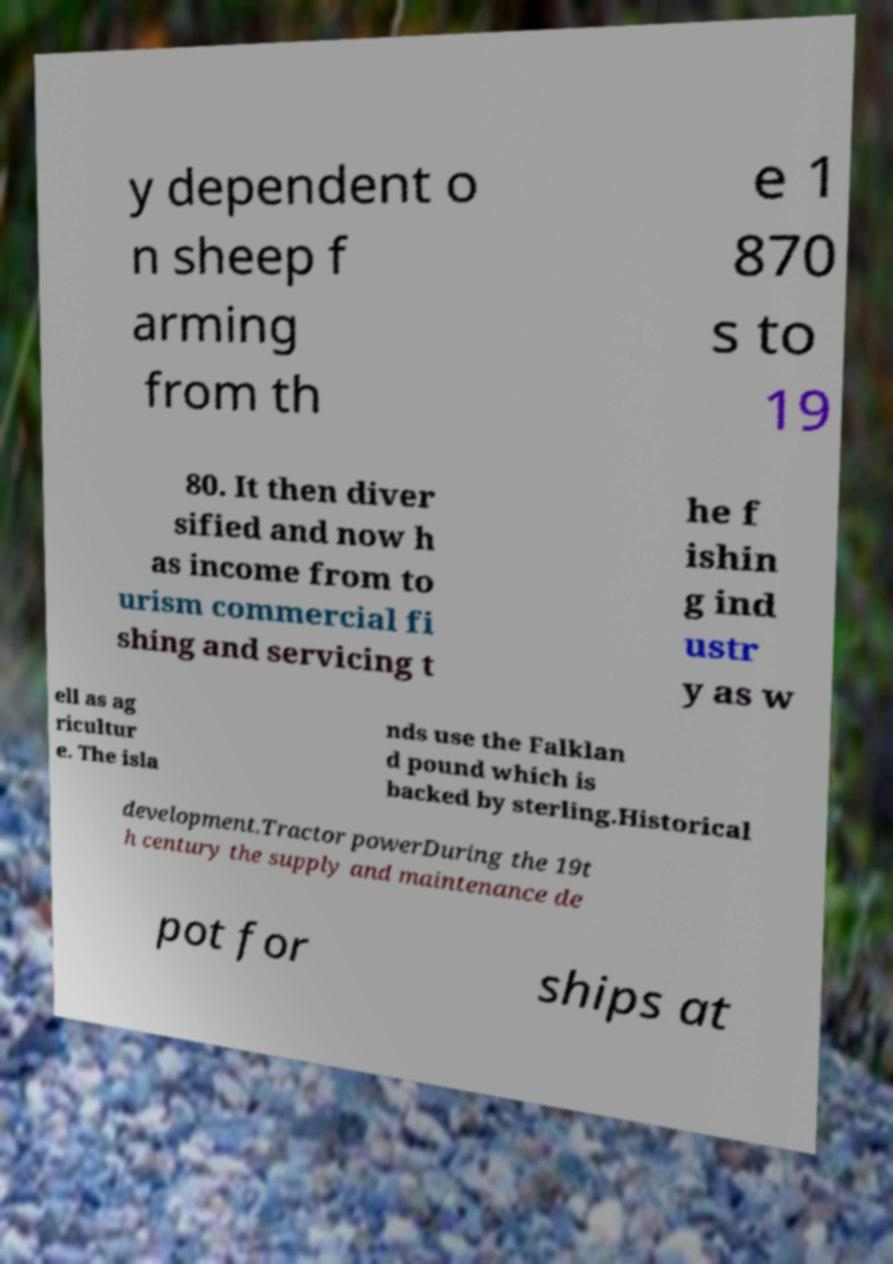Could you assist in decoding the text presented in this image and type it out clearly? y dependent o n sheep f arming from th e 1 870 s to 19 80. It then diver sified and now h as income from to urism commercial fi shing and servicing t he f ishin g ind ustr y as w ell as ag ricultur e. The isla nds use the Falklan d pound which is backed by sterling.Historical development.Tractor powerDuring the 19t h century the supply and maintenance de pot for ships at 